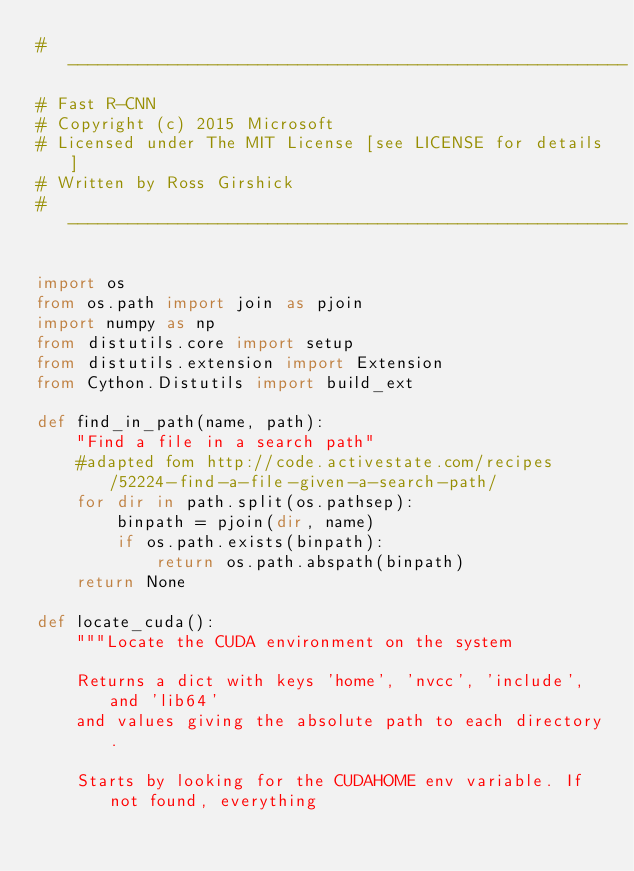<code> <loc_0><loc_0><loc_500><loc_500><_Python_># --------------------------------------------------------
# Fast R-CNN
# Copyright (c) 2015 Microsoft
# Licensed under The MIT License [see LICENSE for details]
# Written by Ross Girshick
# --------------------------------------------------------

import os
from os.path import join as pjoin
import numpy as np
from distutils.core import setup
from distutils.extension import Extension
from Cython.Distutils import build_ext

def find_in_path(name, path):
    "Find a file in a search path"
    #adapted fom http://code.activestate.com/recipes/52224-find-a-file-given-a-search-path/
    for dir in path.split(os.pathsep):
        binpath = pjoin(dir, name)
        if os.path.exists(binpath):
            return os.path.abspath(binpath)
    return None

def locate_cuda():
    """Locate the CUDA environment on the system

    Returns a dict with keys 'home', 'nvcc', 'include', and 'lib64'
    and values giving the absolute path to each directory.

    Starts by looking for the CUDAHOME env variable. If not found, everything</code> 